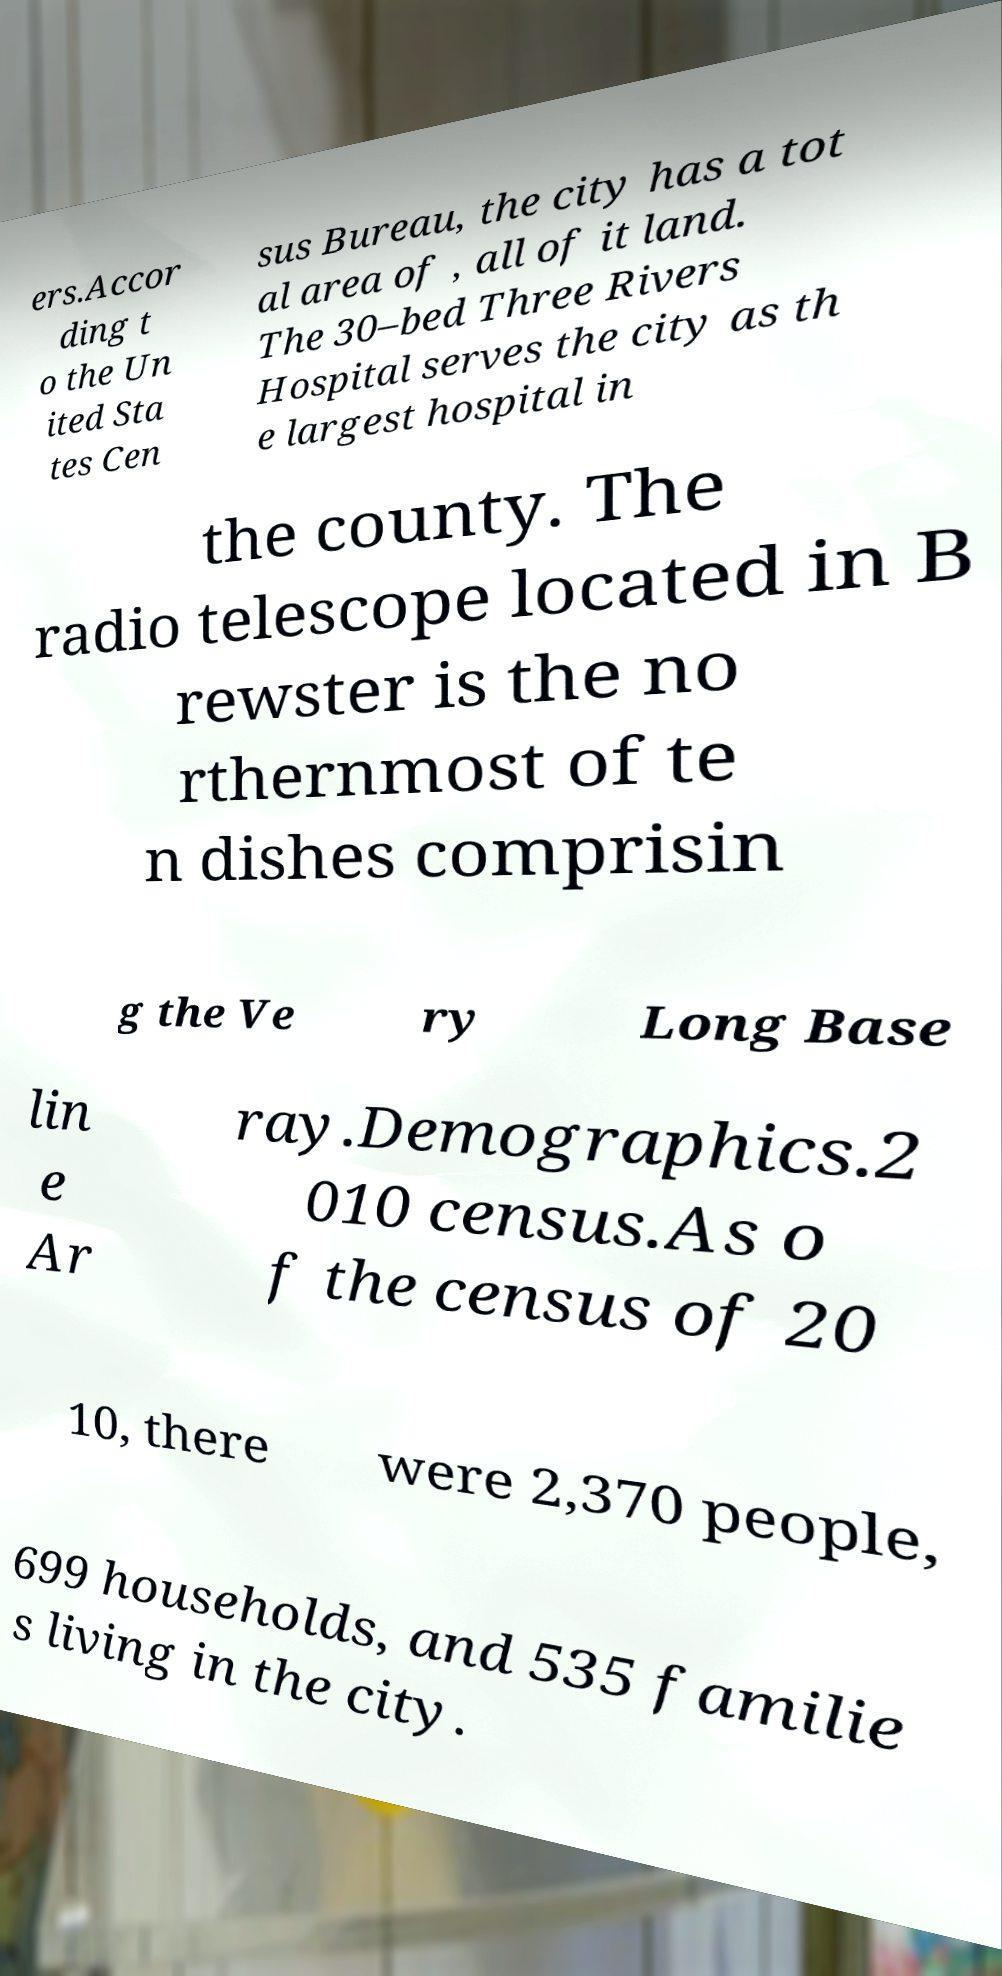I need the written content from this picture converted into text. Can you do that? ers.Accor ding t o the Un ited Sta tes Cen sus Bureau, the city has a tot al area of , all of it land. The 30–bed Three Rivers Hospital serves the city as th e largest hospital in the county. The radio telescope located in B rewster is the no rthernmost of te n dishes comprisin g the Ve ry Long Base lin e Ar ray.Demographics.2 010 census.As o f the census of 20 10, there were 2,370 people, 699 households, and 535 familie s living in the city. 